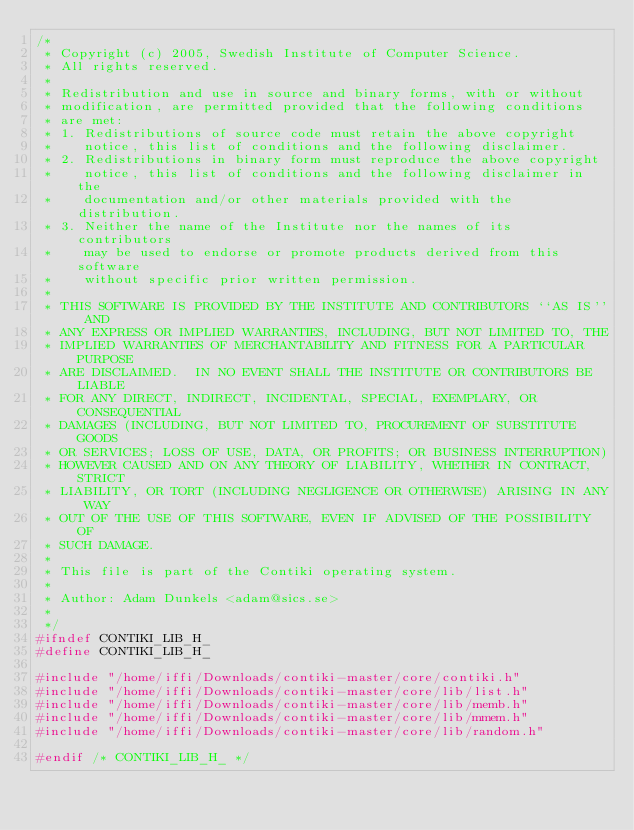<code> <loc_0><loc_0><loc_500><loc_500><_C_>/*
 * Copyright (c) 2005, Swedish Institute of Computer Science.
 * All rights reserved. 
 *
 * Redistribution and use in source and binary forms, with or without 
 * modification, are permitted provided that the following conditions 
 * are met: 
 * 1. Redistributions of source code must retain the above copyright 
 *    notice, this list of conditions and the following disclaimer. 
 * 2. Redistributions in binary form must reproduce the above copyright 
 *    notice, this list of conditions and the following disclaimer in the 
 *    documentation and/or other materials provided with the distribution. 
 * 3. Neither the name of the Institute nor the names of its contributors 
 *    may be used to endorse or promote products derived from this software 
 *    without specific prior written permission. 
 *
 * THIS SOFTWARE IS PROVIDED BY THE INSTITUTE AND CONTRIBUTORS ``AS IS'' AND 
 * ANY EXPRESS OR IMPLIED WARRANTIES, INCLUDING, BUT NOT LIMITED TO, THE 
 * IMPLIED WARRANTIES OF MERCHANTABILITY AND FITNESS FOR A PARTICULAR PURPOSE 
 * ARE DISCLAIMED.  IN NO EVENT SHALL THE INSTITUTE OR CONTRIBUTORS BE LIABLE 
 * FOR ANY DIRECT, INDIRECT, INCIDENTAL, SPECIAL, EXEMPLARY, OR CONSEQUENTIAL 
 * DAMAGES (INCLUDING, BUT NOT LIMITED TO, PROCUREMENT OF SUBSTITUTE GOODS 
 * OR SERVICES; LOSS OF USE, DATA, OR PROFITS; OR BUSINESS INTERRUPTION) 
 * HOWEVER CAUSED AND ON ANY THEORY OF LIABILITY, WHETHER IN CONTRACT, STRICT 
 * LIABILITY, OR TORT (INCLUDING NEGLIGENCE OR OTHERWISE) ARISING IN ANY WAY 
 * OUT OF THE USE OF THIS SOFTWARE, EVEN IF ADVISED OF THE POSSIBILITY OF 
 * SUCH DAMAGE. 
 *
 * This file is part of the Contiki operating system.
 * 
 * Author: Adam Dunkels <adam@sics.se>
 *
 */
#ifndef CONTIKI_LIB_H_
#define CONTIKI_LIB_H_

#include "/home/iffi/Downloads/contiki-master/core/contiki.h"
#include "/home/iffi/Downloads/contiki-master/core/lib/list.h"
#include "/home/iffi/Downloads/contiki-master/core/lib/memb.h"
#include "/home/iffi/Downloads/contiki-master/core/lib/mmem.h"
#include "/home/iffi/Downloads/contiki-master/core/lib/random.h"

#endif /* CONTIKI_LIB_H_ */
</code> 